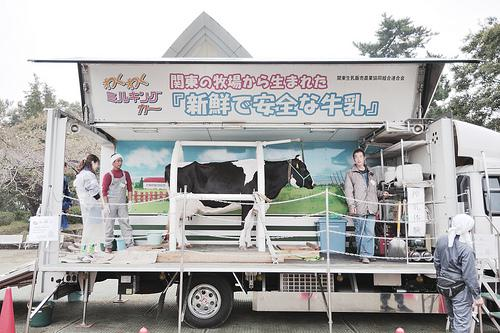Question: what animal is in the picture?
Choices:
A. Pig.
B. Cow.
C. Horse.
D. Chicken.
Answer with the letter. Answer: B Question: where is the man with the covering on his head?
Choices:
A. In the lawn chair.
B. Up on the porch.
C. In the shade of the tree.
D. On the ground near truck.
Answer with the letter. Answer: D 